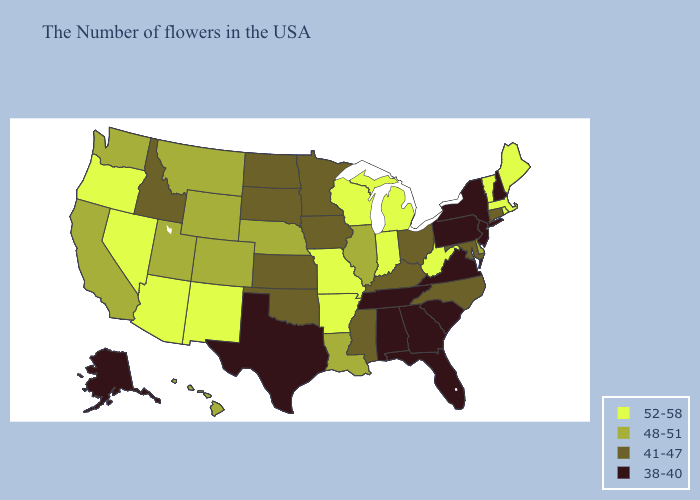Name the states that have a value in the range 52-58?
Write a very short answer. Maine, Massachusetts, Rhode Island, Vermont, West Virginia, Michigan, Indiana, Wisconsin, Missouri, Arkansas, New Mexico, Arizona, Nevada, Oregon. Among the states that border Georgia , does North Carolina have the lowest value?
Keep it brief. No. What is the lowest value in the West?
Keep it brief. 38-40. What is the highest value in the USA?
Be succinct. 52-58. What is the value of Minnesota?
Be succinct. 41-47. Among the states that border Washington , which have the lowest value?
Keep it brief. Idaho. Name the states that have a value in the range 48-51?
Answer briefly. Delaware, Illinois, Louisiana, Nebraska, Wyoming, Colorado, Utah, Montana, California, Washington, Hawaii. What is the value of Missouri?
Be succinct. 52-58. Is the legend a continuous bar?
Answer briefly. No. What is the value of Connecticut?
Keep it brief. 41-47. What is the highest value in the Northeast ?
Quick response, please. 52-58. What is the lowest value in the Northeast?
Keep it brief. 38-40. What is the highest value in states that border New Jersey?
Be succinct. 48-51. What is the lowest value in states that border North Carolina?
Short answer required. 38-40. Which states have the lowest value in the USA?
Concise answer only. New Hampshire, New York, New Jersey, Pennsylvania, Virginia, South Carolina, Florida, Georgia, Alabama, Tennessee, Texas, Alaska. 